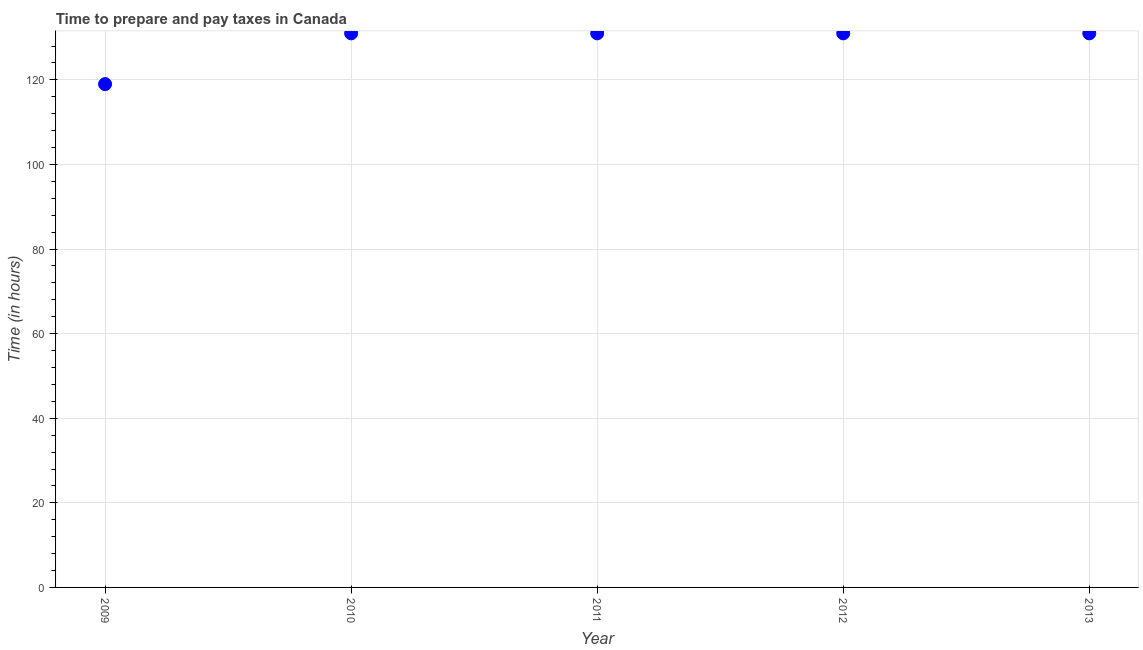What is the time to prepare and pay taxes in 2009?
Make the answer very short. 119. Across all years, what is the maximum time to prepare and pay taxes?
Your response must be concise. 131. Across all years, what is the minimum time to prepare and pay taxes?
Provide a short and direct response. 119. What is the sum of the time to prepare and pay taxes?
Give a very brief answer. 643. What is the difference between the time to prepare and pay taxes in 2012 and 2013?
Your response must be concise. 0. What is the average time to prepare and pay taxes per year?
Offer a terse response. 128.6. What is the median time to prepare and pay taxes?
Make the answer very short. 131. In how many years, is the time to prepare and pay taxes greater than 60 hours?
Keep it short and to the point. 5. Do a majority of the years between 2013 and 2009 (inclusive) have time to prepare and pay taxes greater than 68 hours?
Offer a very short reply. Yes. What is the ratio of the time to prepare and pay taxes in 2009 to that in 2011?
Offer a terse response. 0.91. What is the difference between the highest and the second highest time to prepare and pay taxes?
Your answer should be very brief. 0. What is the difference between the highest and the lowest time to prepare and pay taxes?
Give a very brief answer. 12. Does the graph contain any zero values?
Offer a very short reply. No. What is the title of the graph?
Your response must be concise. Time to prepare and pay taxes in Canada. What is the label or title of the Y-axis?
Make the answer very short. Time (in hours). What is the Time (in hours) in 2009?
Provide a short and direct response. 119. What is the Time (in hours) in 2010?
Your answer should be very brief. 131. What is the Time (in hours) in 2011?
Your answer should be very brief. 131. What is the Time (in hours) in 2012?
Provide a succinct answer. 131. What is the Time (in hours) in 2013?
Offer a very short reply. 131. What is the difference between the Time (in hours) in 2009 and 2011?
Your answer should be compact. -12. What is the difference between the Time (in hours) in 2009 and 2012?
Your answer should be very brief. -12. What is the difference between the Time (in hours) in 2011 and 2013?
Your answer should be very brief. 0. What is the ratio of the Time (in hours) in 2009 to that in 2010?
Provide a short and direct response. 0.91. What is the ratio of the Time (in hours) in 2009 to that in 2011?
Provide a short and direct response. 0.91. What is the ratio of the Time (in hours) in 2009 to that in 2012?
Keep it short and to the point. 0.91. What is the ratio of the Time (in hours) in 2009 to that in 2013?
Your answer should be very brief. 0.91. What is the ratio of the Time (in hours) in 2011 to that in 2013?
Give a very brief answer. 1. 